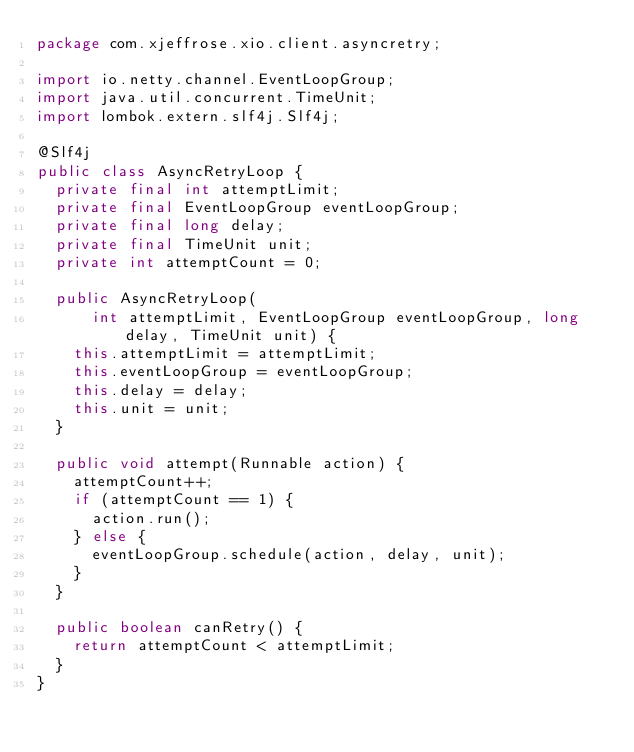Convert code to text. <code><loc_0><loc_0><loc_500><loc_500><_Java_>package com.xjeffrose.xio.client.asyncretry;

import io.netty.channel.EventLoopGroup;
import java.util.concurrent.TimeUnit;
import lombok.extern.slf4j.Slf4j;

@Slf4j
public class AsyncRetryLoop {
  private final int attemptLimit;
  private final EventLoopGroup eventLoopGroup;
  private final long delay;
  private final TimeUnit unit;
  private int attemptCount = 0;

  public AsyncRetryLoop(
      int attemptLimit, EventLoopGroup eventLoopGroup, long delay, TimeUnit unit) {
    this.attemptLimit = attemptLimit;
    this.eventLoopGroup = eventLoopGroup;
    this.delay = delay;
    this.unit = unit;
  }

  public void attempt(Runnable action) {
    attemptCount++;
    if (attemptCount == 1) {
      action.run();
    } else {
      eventLoopGroup.schedule(action, delay, unit);
    }
  }

  public boolean canRetry() {
    return attemptCount < attemptLimit;
  }
}
</code> 